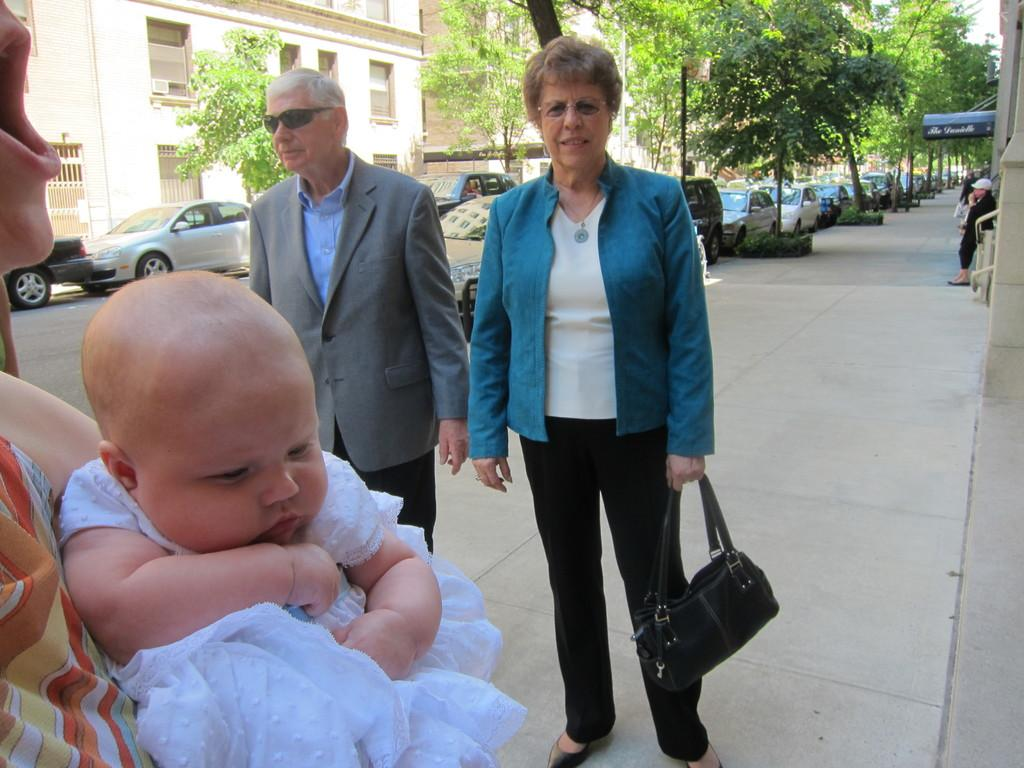What type of structure is visible in the image? There is a building in the image. What other elements can be seen in the image? There are trees, cars, and people standing on the road in the image. Can you describe the woman in the image? The woman is standing in the image and is holding a black color bag. What type of bells can be heard ringing in the image? There are no bells present in the image, and therefore no sound can be heard. 